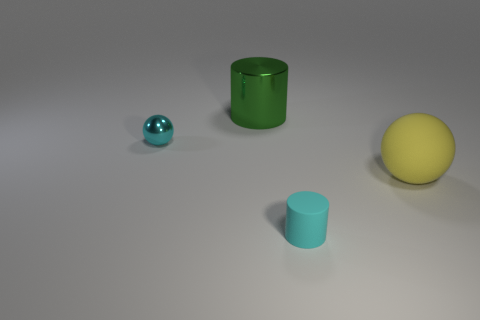Add 1 tiny cyan matte cylinders. How many objects exist? 5 Add 1 yellow spheres. How many yellow spheres are left? 2 Add 1 metal balls. How many metal balls exist? 2 Subtract 0 yellow cylinders. How many objects are left? 4 Subtract all cyan rubber things. Subtract all cyan spheres. How many objects are left? 2 